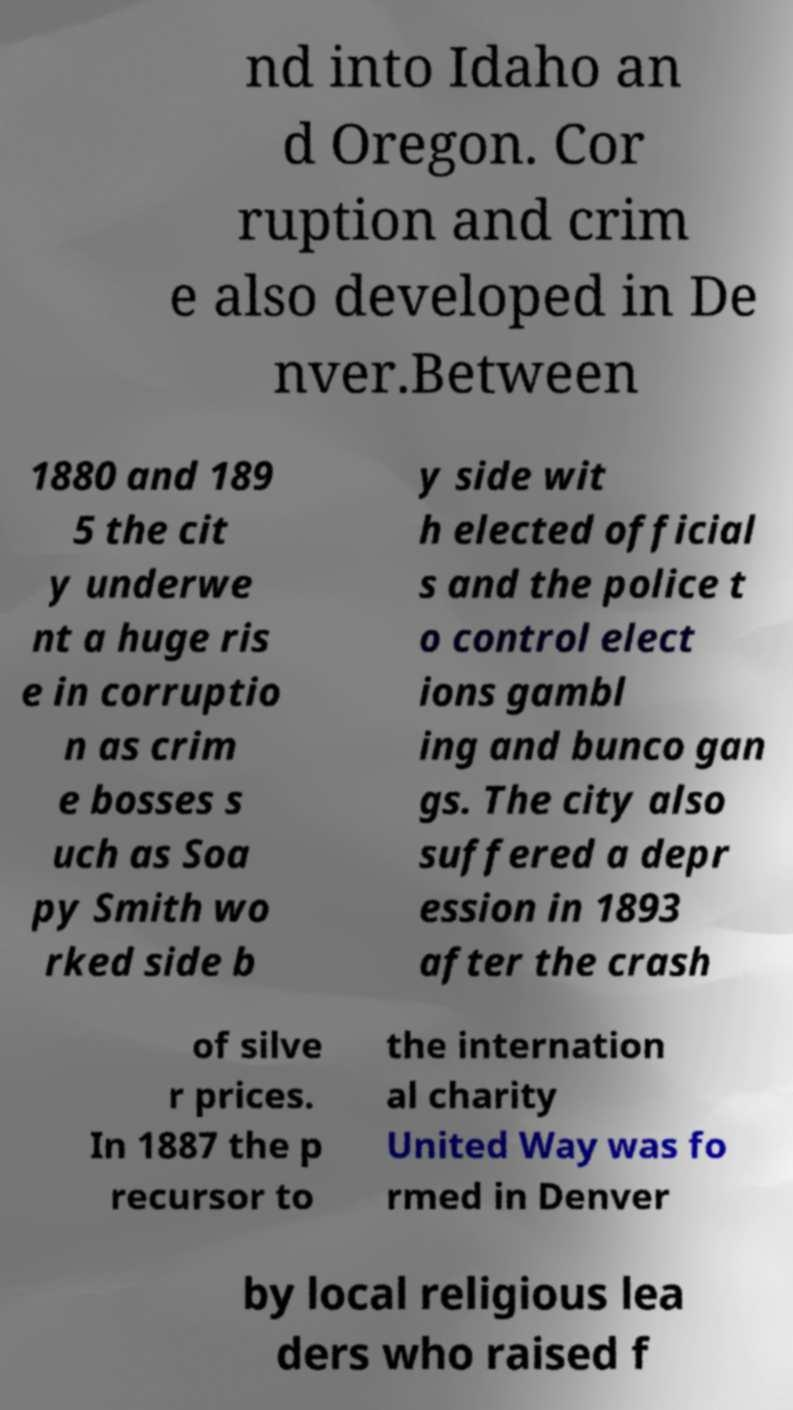Please identify and transcribe the text found in this image. nd into Idaho an d Oregon. Cor ruption and crim e also developed in De nver.Between 1880 and 189 5 the cit y underwe nt a huge ris e in corruptio n as crim e bosses s uch as Soa py Smith wo rked side b y side wit h elected official s and the police t o control elect ions gambl ing and bunco gan gs. The city also suffered a depr ession in 1893 after the crash of silve r prices. In 1887 the p recursor to the internation al charity United Way was fo rmed in Denver by local religious lea ders who raised f 